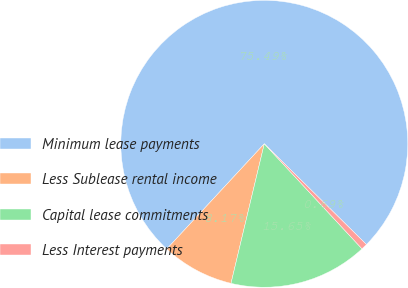Convert chart. <chart><loc_0><loc_0><loc_500><loc_500><pie_chart><fcel>Minimum lease payments<fcel>Less Sublease rental income<fcel>Capital lease commitments<fcel>Less Interest payments<nl><fcel>75.48%<fcel>8.17%<fcel>15.65%<fcel>0.69%<nl></chart> 